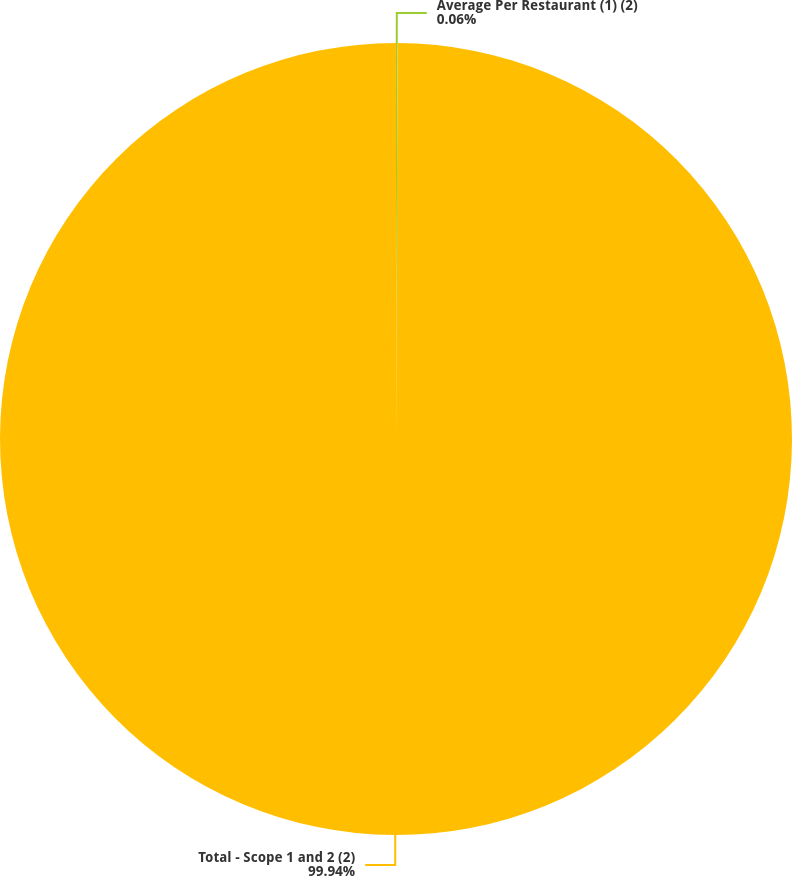Convert chart. <chart><loc_0><loc_0><loc_500><loc_500><pie_chart><fcel>Average Per Restaurant (1) (2)<fcel>Total - Scope 1 and 2 (2)<nl><fcel>0.06%<fcel>99.94%<nl></chart> 